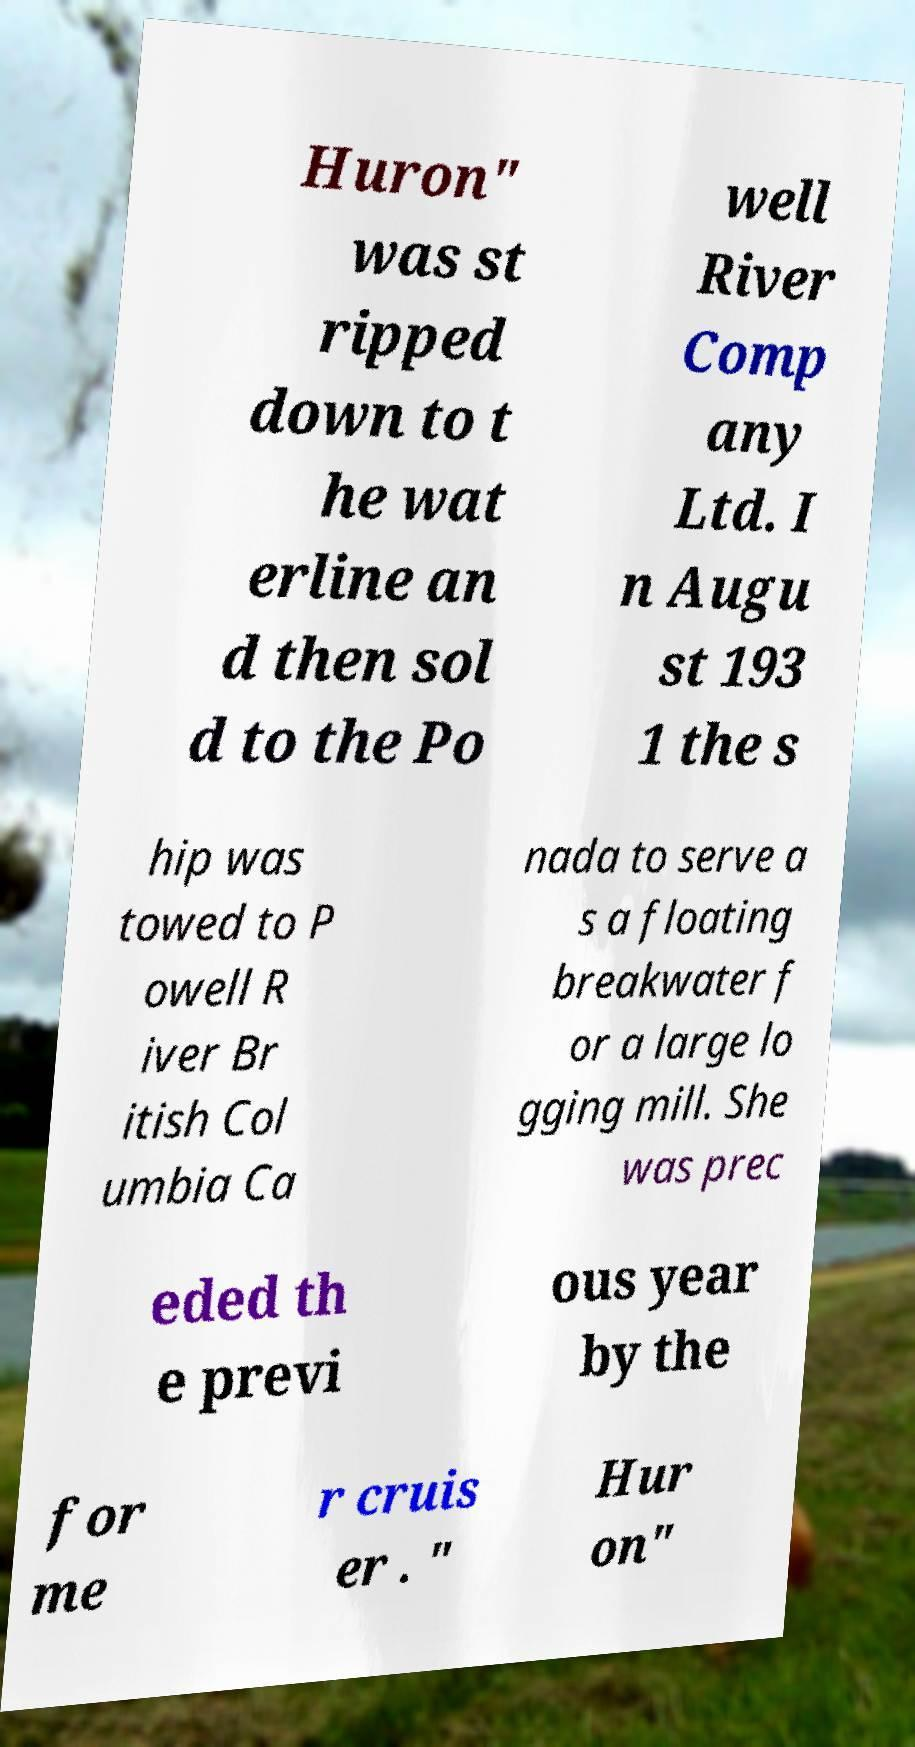I need the written content from this picture converted into text. Can you do that? Huron" was st ripped down to t he wat erline an d then sol d to the Po well River Comp any Ltd. I n Augu st 193 1 the s hip was towed to P owell R iver Br itish Col umbia Ca nada to serve a s a floating breakwater f or a large lo gging mill. She was prec eded th e previ ous year by the for me r cruis er . " Hur on" 